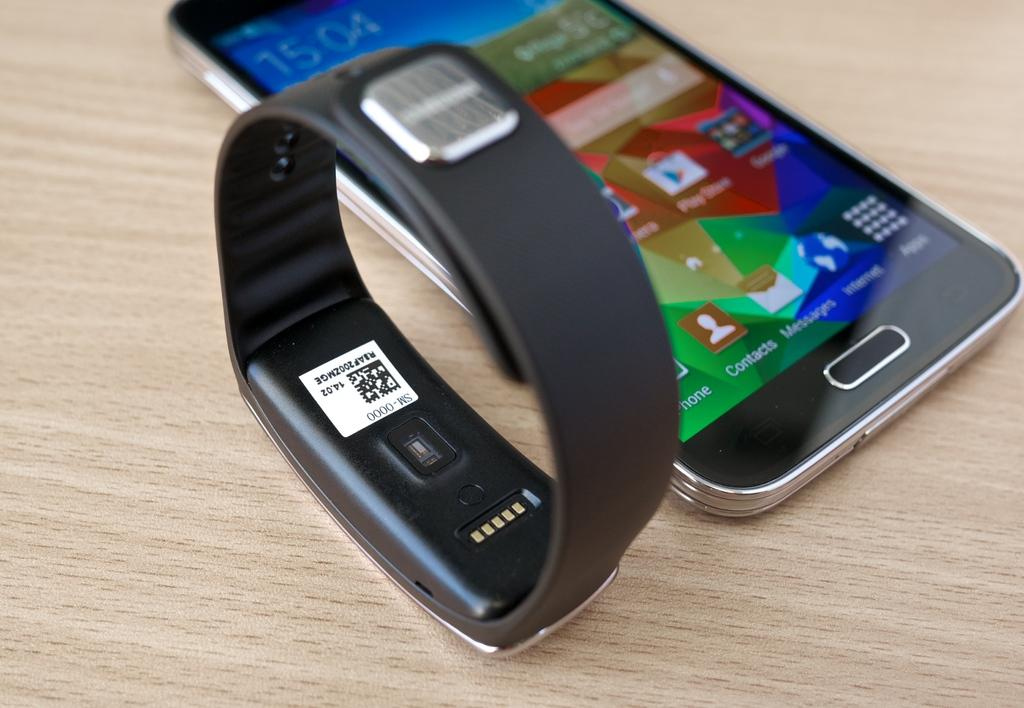<image>
Present a compact description of the photo's key features. A fitbit and smart phone displaying the time of 15:04 